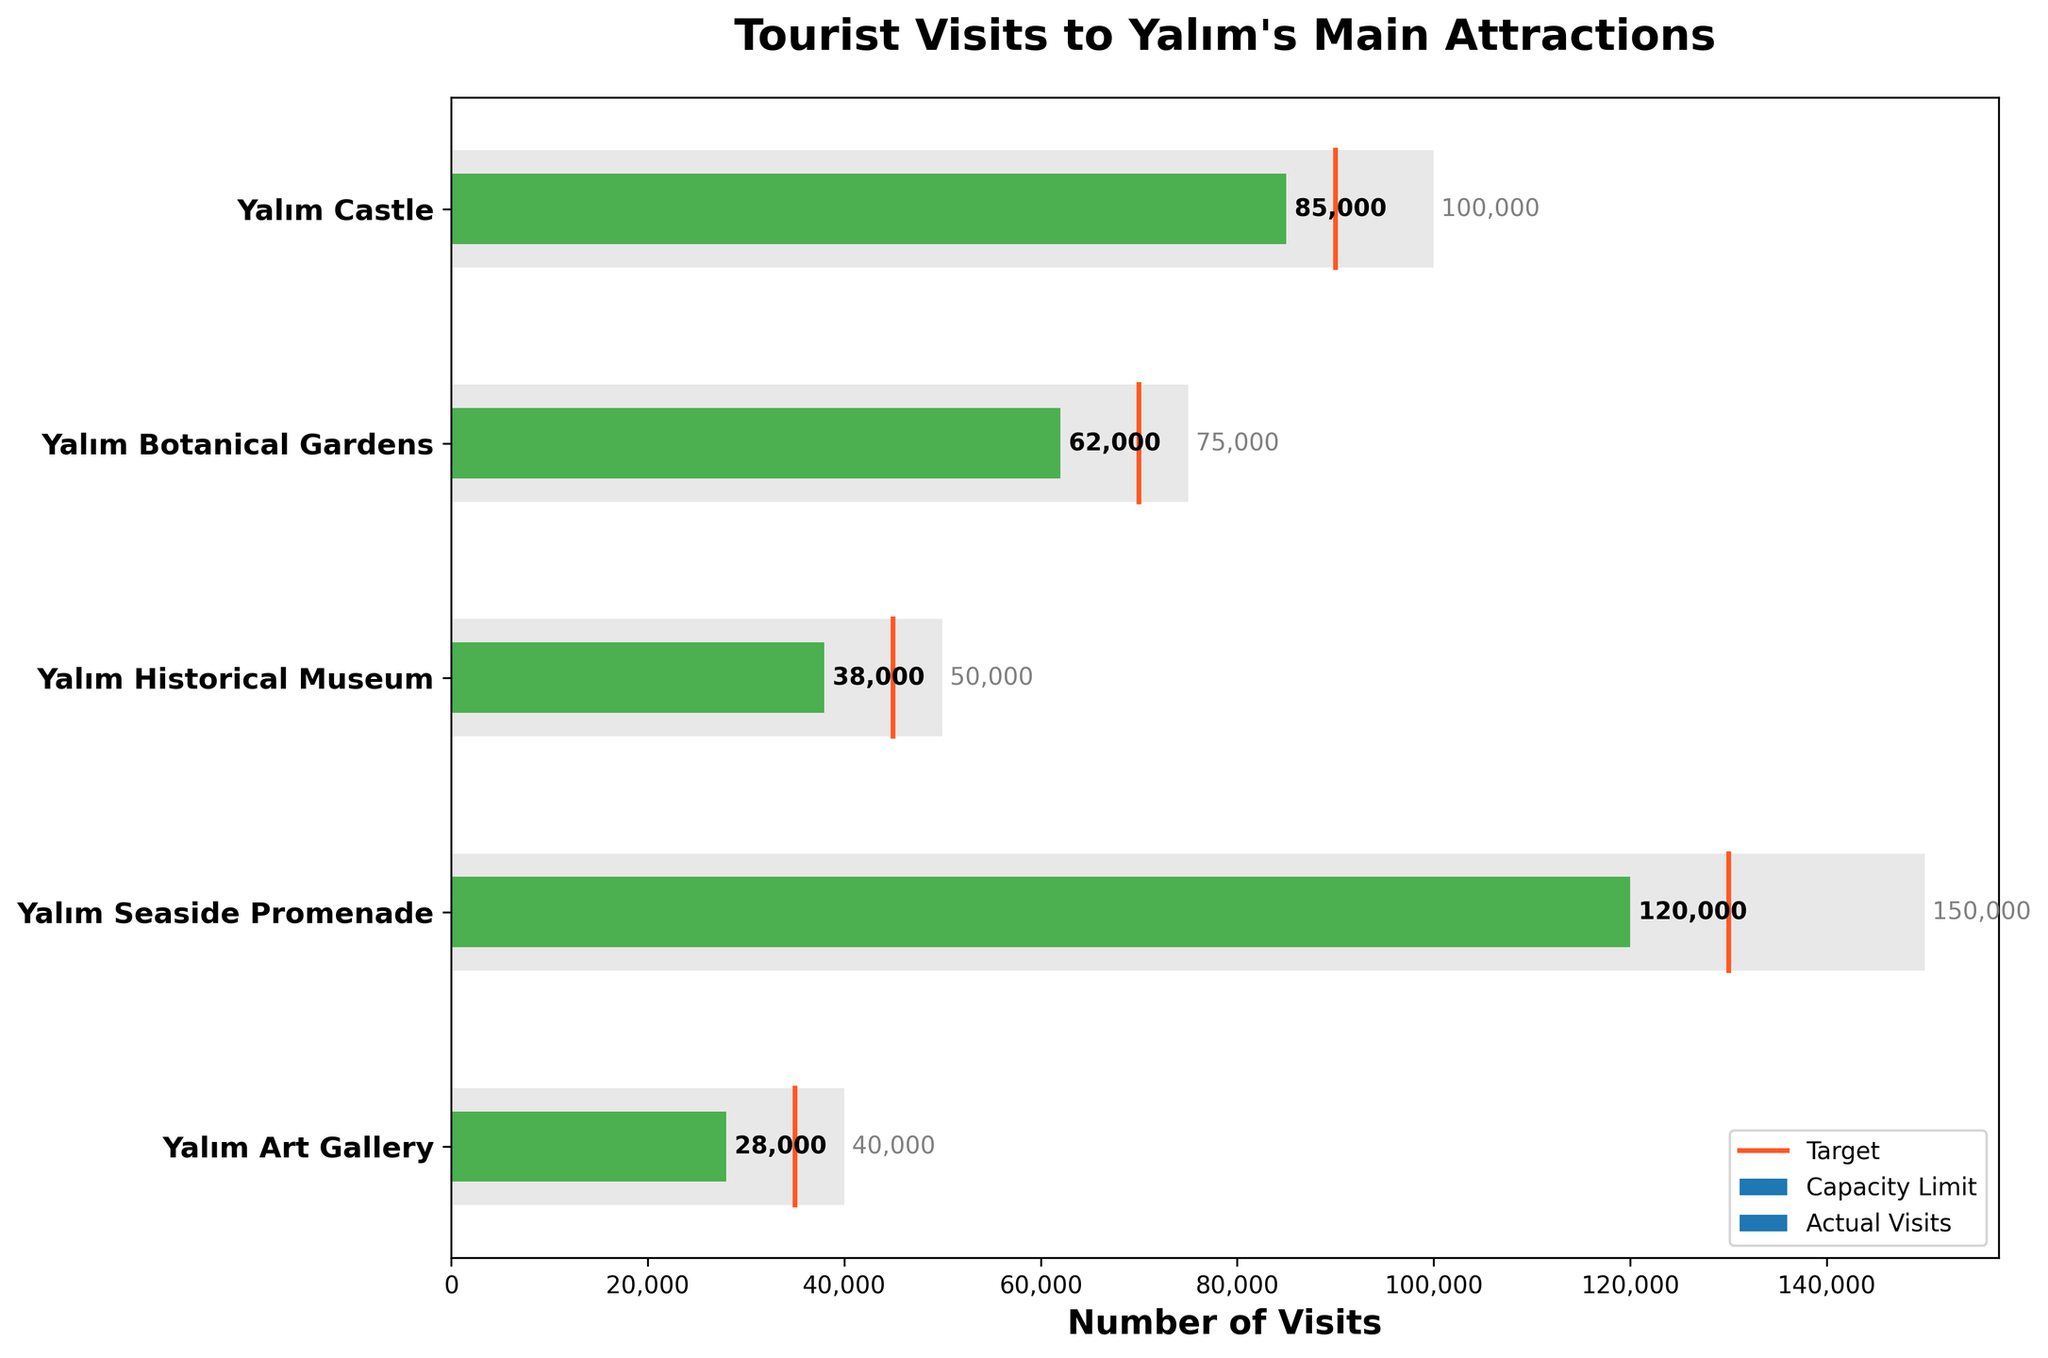What is the title of the figure? The title is displayed at the top of the figure, above the bullet chart, providing an overview of the data presented.
Answer: Tourist Visits to Yalım's Main Attractions Which attraction has the highest number of actual visits? Look at the green bars representing actual visits, and identify the longest one.
Answer: Yalım Seaside Promenade How does the number of actual visits to Yalım Castle compare to its target? Find the green bar for Yalım Castle and check its length against the position of the orange target line.
Answer: Less than the target Which attraction most closely reached its target visit number? Compare the green bars (actual visits) with the orange lines (targets) and find the smallest difference.
Answer: Yalım Historical Museum How many attractions have actual visits greater than their capacity limits? Compare the lengths of the green bars (actual visits) to the capacity limits (end of the light grey bars) for each attraction. Count how many exceed.
Answer: 0 What is the total number of actual visits to all attractions? Sum all the values represented by the green bars (actual visits): 85000, 62000, 38000, 120000, 28000.
Answer: 333,000 What is the difference in actual visits between Yalım Castle and Yalım Botanical Gardens? Subtract the number of actual visits for Yalım Botanical Gardens from the number of actual visits for Yalım Castle: 85000 - 62000.
Answer: 23,000 Which attraction has the largest difference between its capacity limit and actual visits? For each attraction, subtract the actual visits (green bars) from the capacity limit (end of the light grey bars) and find the largest difference.
Answer: Yalım Seaside Promenade What percentage of the capacity limit has Yalım Castle reached in actual visits? Divide the actual visits by the capacity limit for Yalım Castle and multiply by 100: (85000 / 100000) * 100.
Answer: 85% Which attraction surpassed the lowest target visit number among all the attractions? Identify the smallest target value (orange line) and check which attraction’s actual visits (green bar) exceeded it.
Answer: Yalım Botanical Gardens 